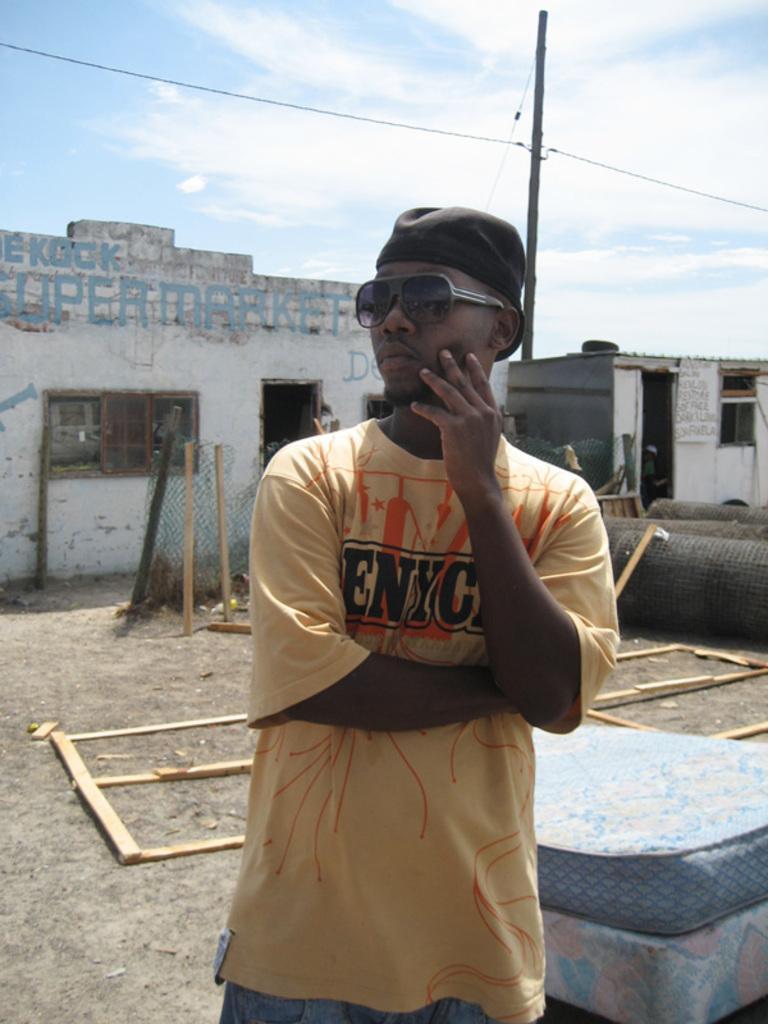Describe this image in one or two sentences. The man in the middle of the picture wearing yellow color t-shirt and black cap is standing. He is even wearing goggles. Beside him, we see a blue color thing which looks like a bed. Behind him, we see wooden sticks and a fence. Behind that, there are buildings which are in white color with some text written on it. At the top of the picture, we see the sky, electric pole and the wires. 